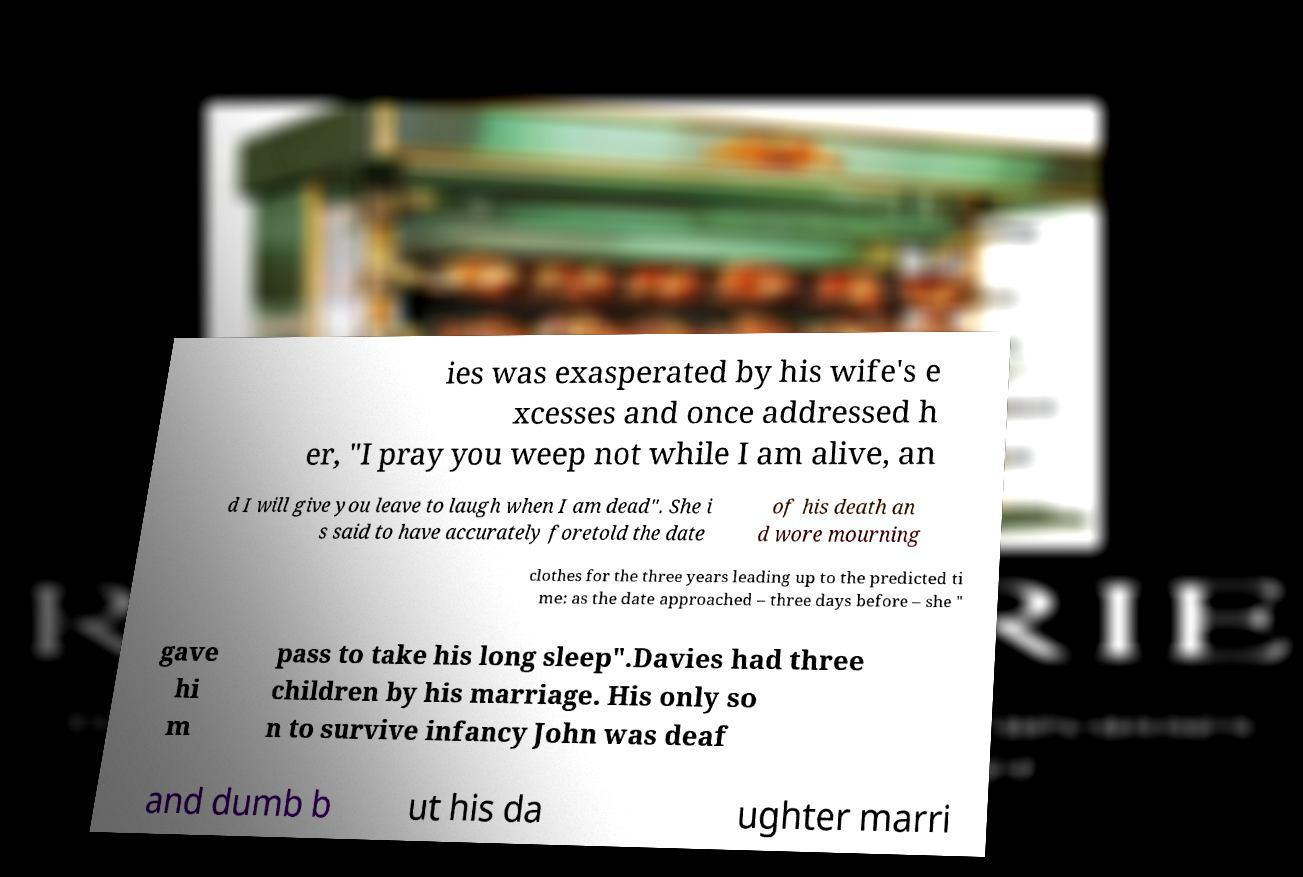Please identify and transcribe the text found in this image. ies was exasperated by his wife's e xcesses and once addressed h er, "I pray you weep not while I am alive, an d I will give you leave to laugh when I am dead". She i s said to have accurately foretold the date of his death an d wore mourning clothes for the three years leading up to the predicted ti me: as the date approached – three days before – she " gave hi m pass to take his long sleep".Davies had three children by his marriage. His only so n to survive infancy John was deaf and dumb b ut his da ughter marri 